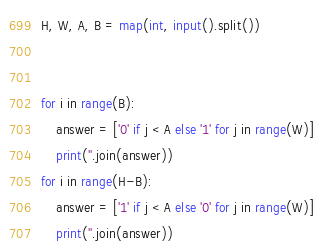Convert code to text. <code><loc_0><loc_0><loc_500><loc_500><_Python_>H, W, A, B = map(int, input().split())


for i in range(B):
    answer = ['0' if j < A else '1' for j in range(W)]
    print(''.join(answer))
for i in range(H-B):
    answer = ['1' if j < A else '0' for j in range(W)]
    print(''.join(answer))</code> 